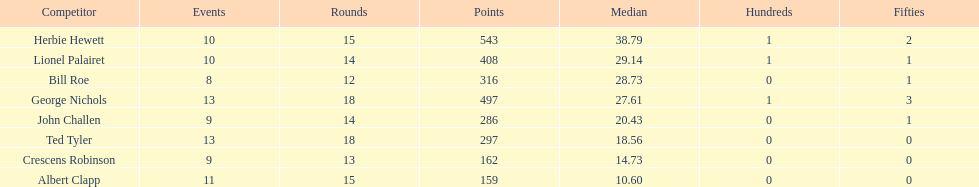Name a player whose average was above 25. Herbie Hewett. 